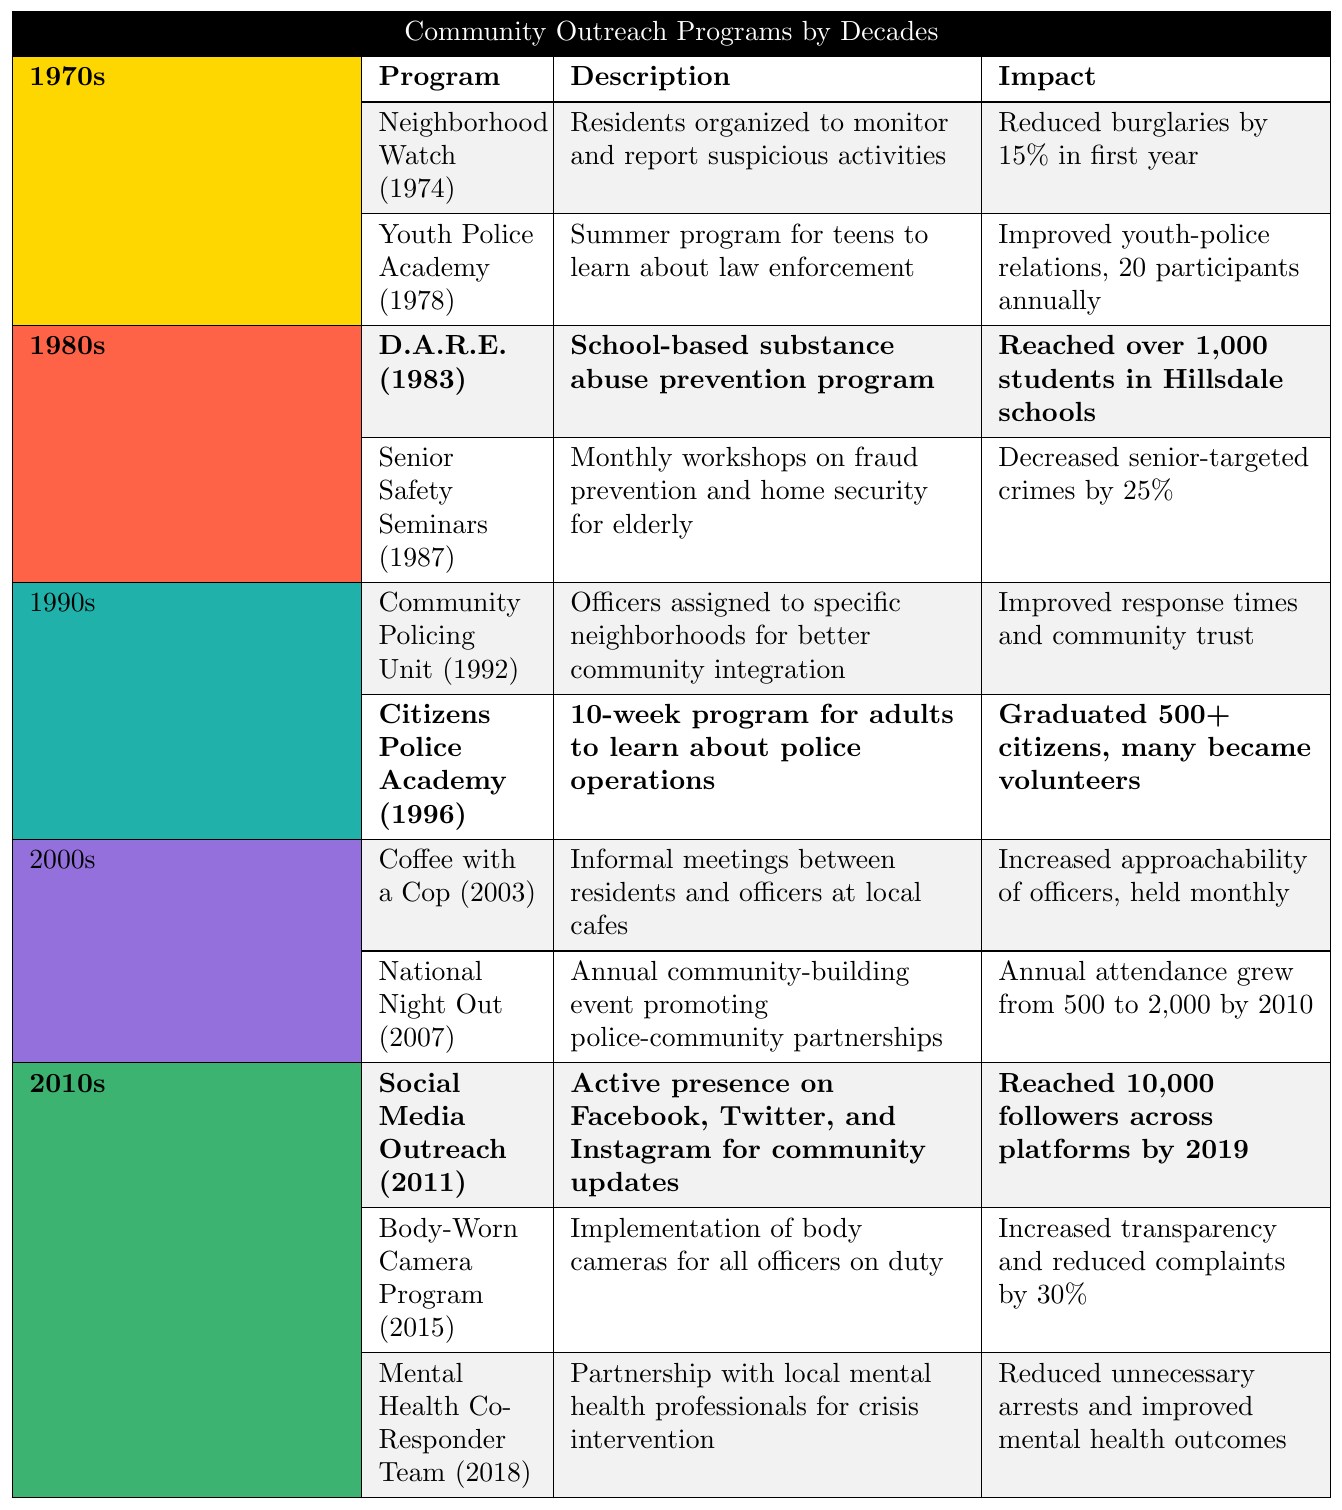What program was introduced in the 1970s that aimed to improve youth-police relations? The table indicates that the "Youth Police Academy," introduced in 1978, was specifically designed to improve youth-police relations.
Answer: Youth Police Academy How many participants annually did the Youth Police Academy have? According to the table, the Youth Police Academy had 20 participants annually.
Answer: 20 participants Which program in the 1980s contributed to a decrease in senior-targeted crimes? The "Senior Safety Seminars," introduced in 1987, aimed to reduce senior-targeted crimes by providing monthly workshops on fraud prevention and home security.
Answer: Senior Safety Seminars What was the impact of the D.A.R.E. program introduced in 1983? The impact of the D.A.R.E. program was that it reached over 1,000 students in Hillsdale schools, aiming to prevent substance abuse.
Answer: Reached over 1,000 students How many citizens graduated from the Citizens Police Academy by 1996? The table states that over 500 citizens graduated from the Citizens Police Academy by 1996.
Answer: Over 500 citizens Between which years was the Community Policing Unit introduced? The Community Policing Unit was introduced in 1992 and provided improved community integration.
Answer: 1992 How did the National Night Out event grow in attendance from its inception to 2010? The table mentions that attendance grew from 500 in the beginning to 2,000 by 2010, indicating a growth in community engagement.
Answer: Increased from 500 to 2,000 attendees What percentage decrease in complaints did the Body-Worn Camera Program achieve? The Body-Worn Camera Program, introduced in 2015, led to a 30% reduction in complaints.
Answer: 30% decrease Can you identify the decade in which the Mental Health Co-Responder Team was introduced? The Mental Health Co-Responder Team was introduced in 2018, which is part of the 2010s decade.
Answer: 2010s What is the main goal of the Social Media Outreach program? The objective of the Social Media Outreach program, launched in 2011, was to maintain an active presence on social media for community updates.
Answer: Community updates How many outreach programs were introduced in the 2010s compared to the 1980s? The table shows there were three programs in the 2010s (Social Media Outreach, Body-Worn Camera Program, Mental Health Co-Responder Team) and two programs in the 1980s (D.A.R.E. and Senior Safety Seminars). Therefore, the 2010s had one more than the 1980s.
Answer: 3 in the 2010s, 2 in the 1980s Which program had the most direct impact on improving transparency? The Body-Worn Camera Program is specifically noted for increasing transparency among officers, resulting in a decrease in complaints.
Answer: Body-Worn Camera Program What decade saw the introduction of the Coffee with a Cop program? The Coffee with a Cop program was introduced in 2003, which falls in the 2000s decade.
Answer: 2000s Which decades focused on youth-related outreach initiatives? The 1970s and 1980s both focused on youth-related initiatives, with the "Youth Police Academy" in the 1970s and "D.A.R.E." in the 1980s.
Answer: 1970s and 1980s What was a key feature of the program implemented in the 1990s that focused on community relations? The "Community Policing Unit," introduced in 1992, involved assigning officers to specific neighborhoods to enhance community integration.
Answer: Officers assigned to neighborhoods 